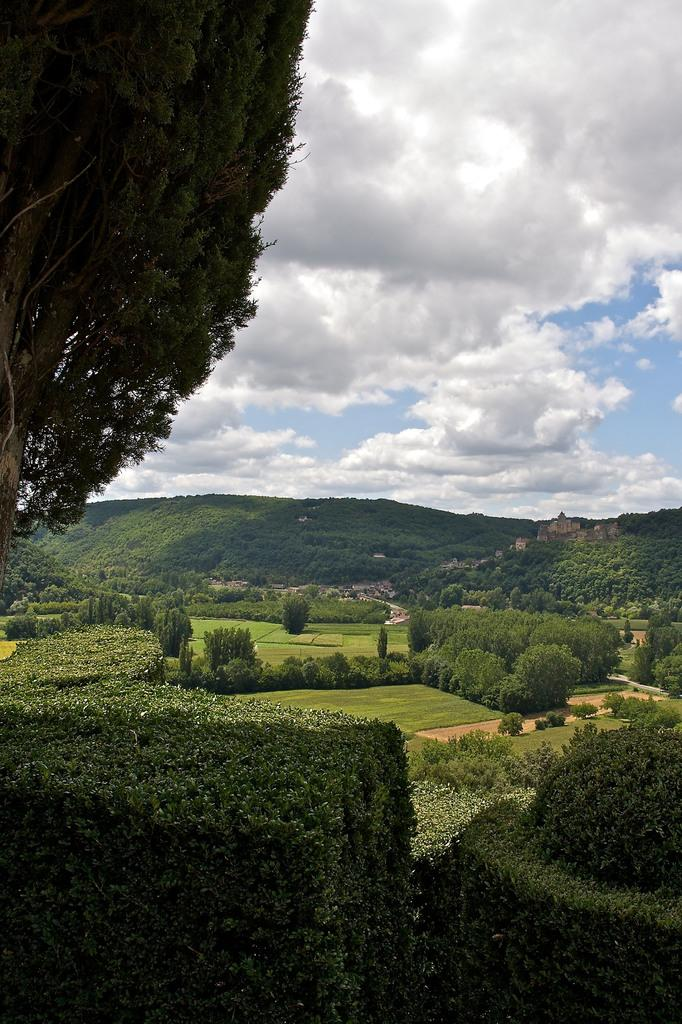What can be seen in the sky in the image? The sky with clouds is visible in the image. What type of landscape feature is present in the image? There are hills in the image. What type of vegetation is present in the image? Trees and bushes are present in the image. What is visible at the bottom of the image? The ground is visible in the image. What type of canvas is used to create the scene in the image? The image is not a painting or artwork, so there is no canvas used to create the scene. What type of iron is visible in the image? There is no iron present in the image. 